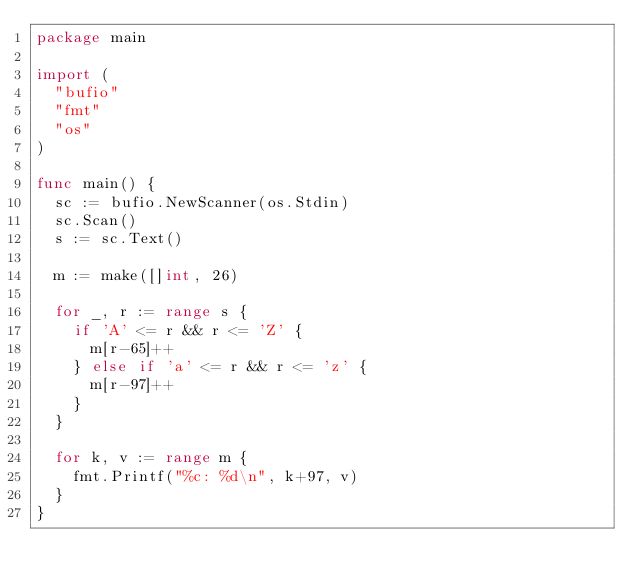<code> <loc_0><loc_0><loc_500><loc_500><_Go_>package main

import (
	"bufio"
	"fmt"
	"os"
)

func main() {
	sc := bufio.NewScanner(os.Stdin)
	sc.Scan()
	s := sc.Text()

	m := make([]int, 26)

	for _, r := range s {
		if 'A' <= r && r <= 'Z' {
			m[r-65]++
		} else if 'a' <= r && r <= 'z' {
			m[r-97]++
		}
	}

	for k, v := range m {
		fmt.Printf("%c: %d\n", k+97, v)
	}
}

</code> 